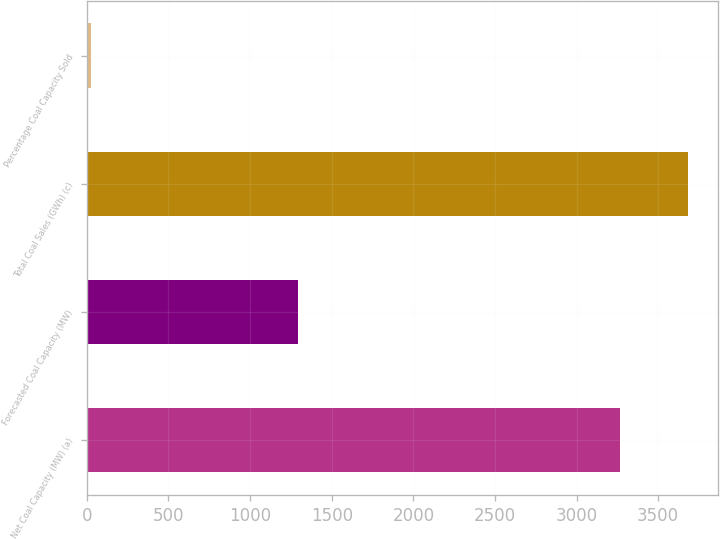<chart> <loc_0><loc_0><loc_500><loc_500><bar_chart><fcel>Net Coal Capacity (MW) (a)<fcel>Forecasted Coal Capacity (MW)<fcel>Total Coal Sales (GWh) (c)<fcel>Percentage Coal Capacity Sold<nl><fcel>3267<fcel>1294<fcel>3683<fcel>27<nl></chart> 